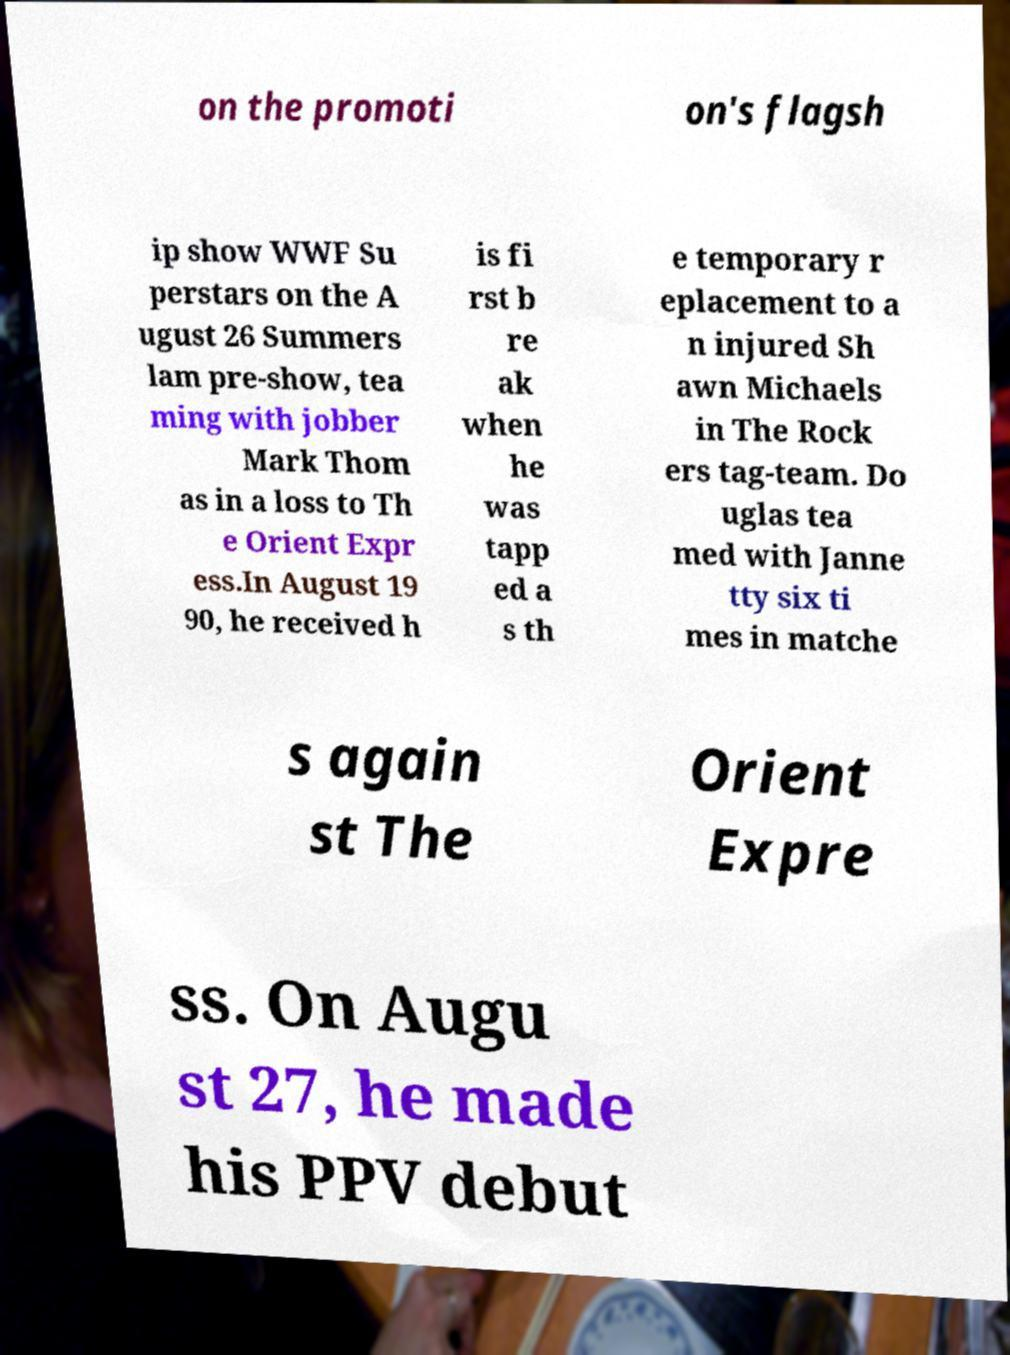Could you assist in decoding the text presented in this image and type it out clearly? on the promoti on's flagsh ip show WWF Su perstars on the A ugust 26 Summers lam pre-show, tea ming with jobber Mark Thom as in a loss to Th e Orient Expr ess.In August 19 90, he received h is fi rst b re ak when he was tapp ed a s th e temporary r eplacement to a n injured Sh awn Michaels in The Rock ers tag-team. Do uglas tea med with Janne tty six ti mes in matche s again st The Orient Expre ss. On Augu st 27, he made his PPV debut 